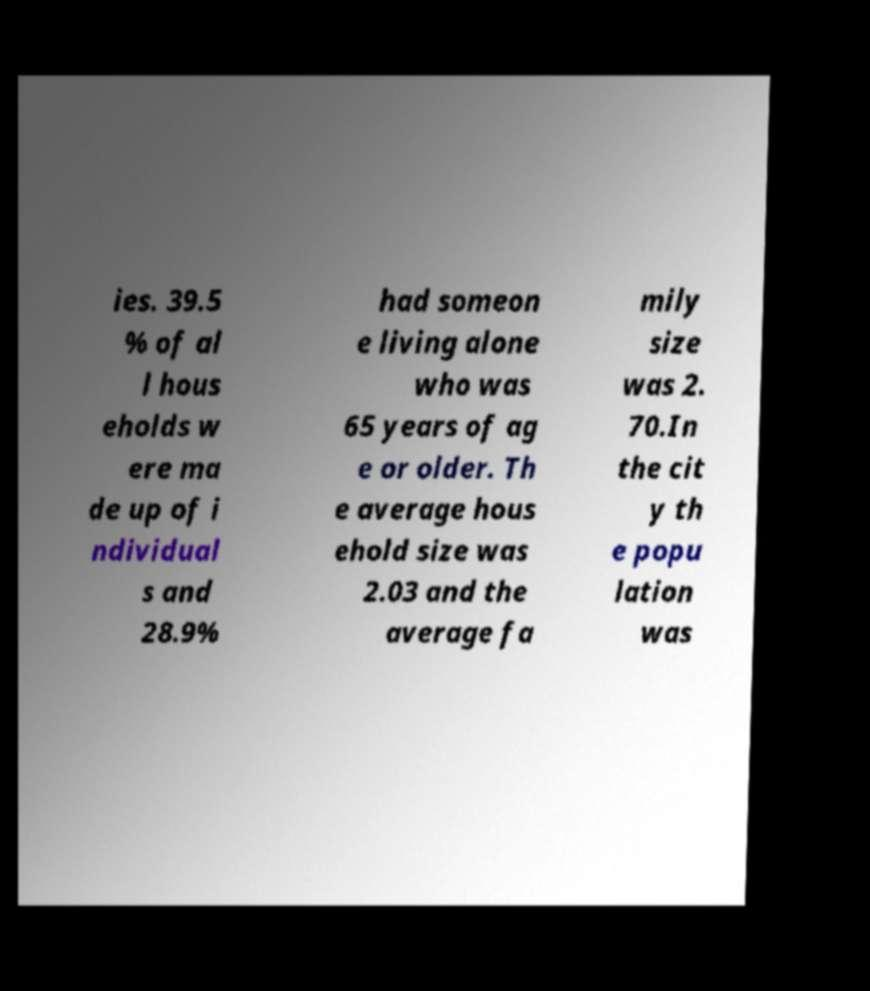Can you accurately transcribe the text from the provided image for me? ies. 39.5 % of al l hous eholds w ere ma de up of i ndividual s and 28.9% had someon e living alone who was 65 years of ag e or older. Th e average hous ehold size was 2.03 and the average fa mily size was 2. 70.In the cit y th e popu lation was 